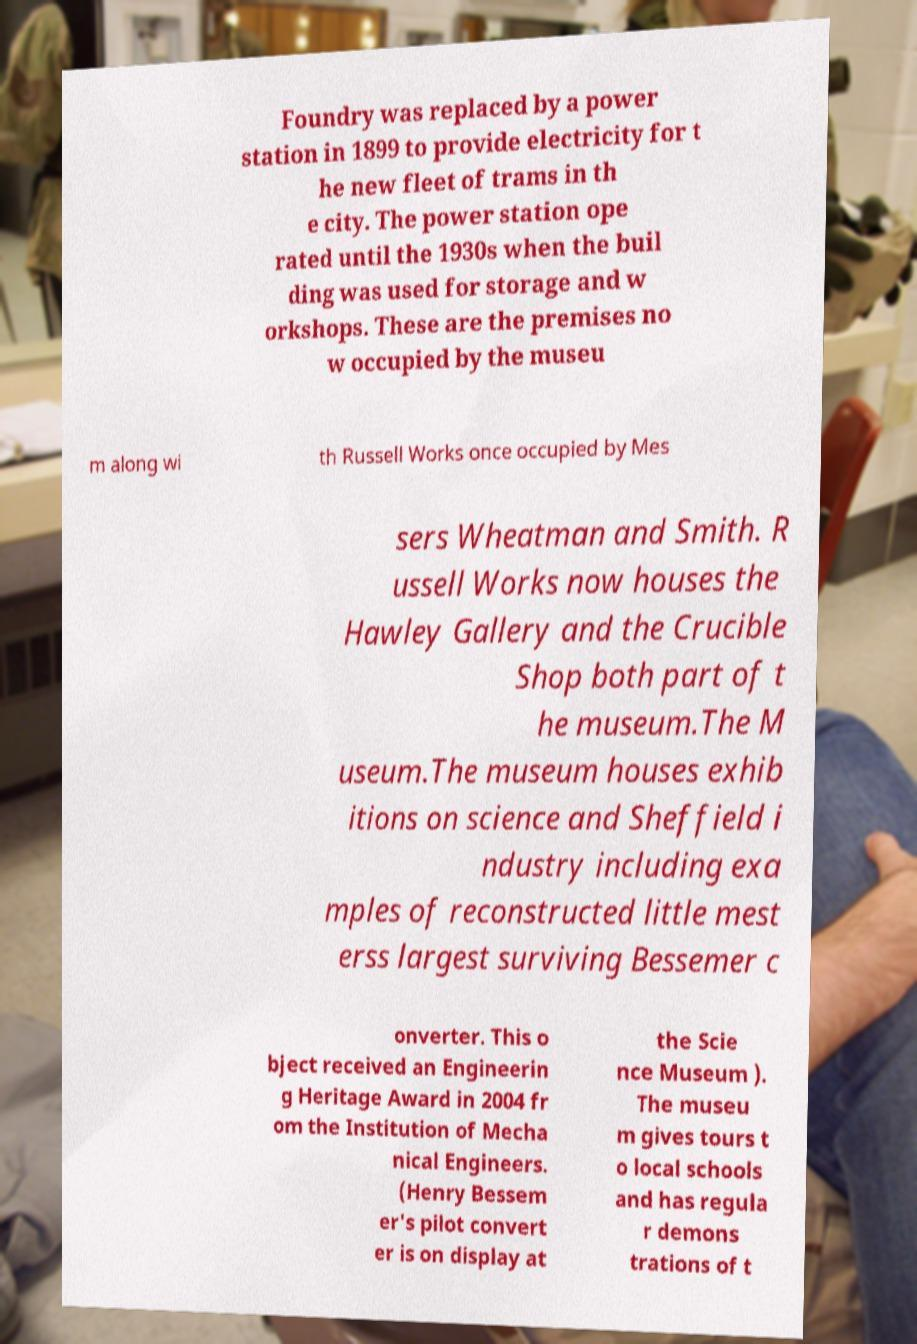Please read and relay the text visible in this image. What does it say? Foundry was replaced by a power station in 1899 to provide electricity for t he new fleet of trams in th e city. The power station ope rated until the 1930s when the buil ding was used for storage and w orkshops. These are the premises no w occupied by the museu m along wi th Russell Works once occupied by Mes sers Wheatman and Smith. R ussell Works now houses the Hawley Gallery and the Crucible Shop both part of t he museum.The M useum.The museum houses exhib itions on science and Sheffield i ndustry including exa mples of reconstructed little mest erss largest surviving Bessemer c onverter. This o bject received an Engineerin g Heritage Award in 2004 fr om the Institution of Mecha nical Engineers. (Henry Bessem er's pilot convert er is on display at the Scie nce Museum ). The museu m gives tours t o local schools and has regula r demons trations of t 